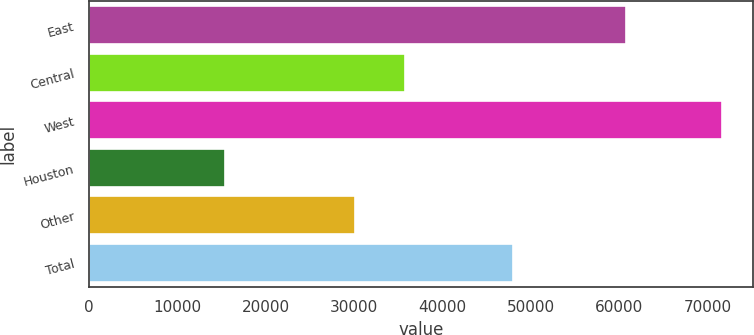Convert chart. <chart><loc_0><loc_0><loc_500><loc_500><bar_chart><fcel>East<fcel>Central<fcel>West<fcel>Houston<fcel>Other<fcel>Total<nl><fcel>60800<fcel>35720<fcel>71600<fcel>15400<fcel>30100<fcel>48000<nl></chart> 